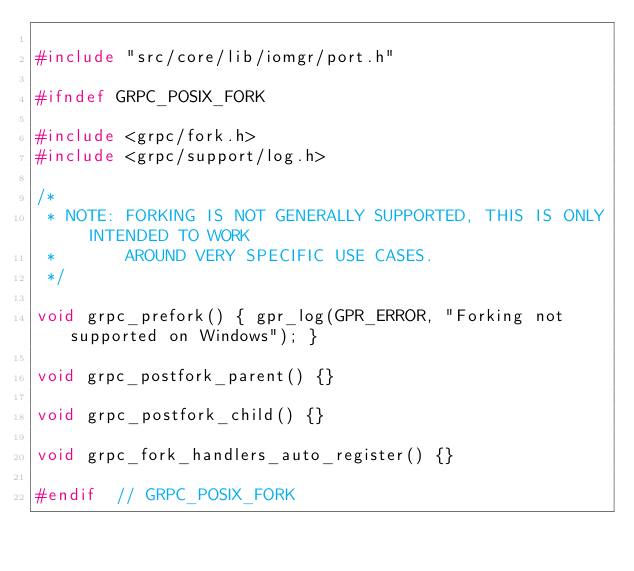<code> <loc_0><loc_0><loc_500><loc_500><_C++_>
#include "src/core/lib/iomgr/port.h"

#ifndef GRPC_POSIX_FORK

#include <grpc/fork.h>
#include <grpc/support/log.h>

/*
 * NOTE: FORKING IS NOT GENERALLY SUPPORTED, THIS IS ONLY INTENDED TO WORK
 *       AROUND VERY SPECIFIC USE CASES.
 */

void grpc_prefork() { gpr_log(GPR_ERROR, "Forking not supported on Windows"); }

void grpc_postfork_parent() {}

void grpc_postfork_child() {}

void grpc_fork_handlers_auto_register() {}

#endif  // GRPC_POSIX_FORK
</code> 